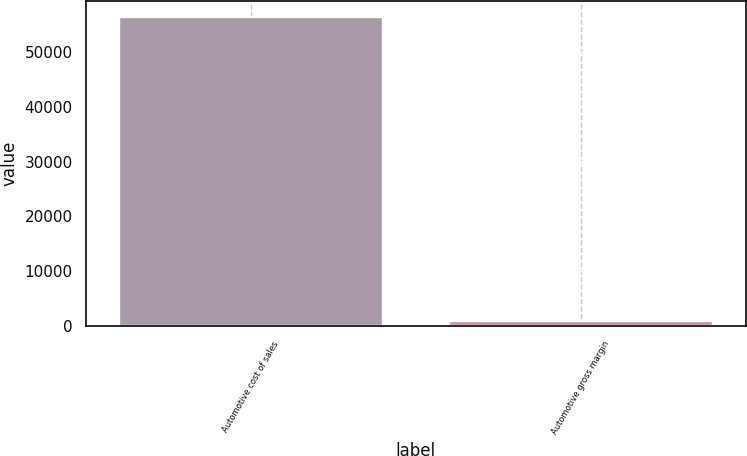<chart> <loc_0><loc_0><loc_500><loc_500><bar_chart><fcel>Automotive cost of sales<fcel>Automotive gross margin<nl><fcel>56381<fcel>948<nl></chart> 